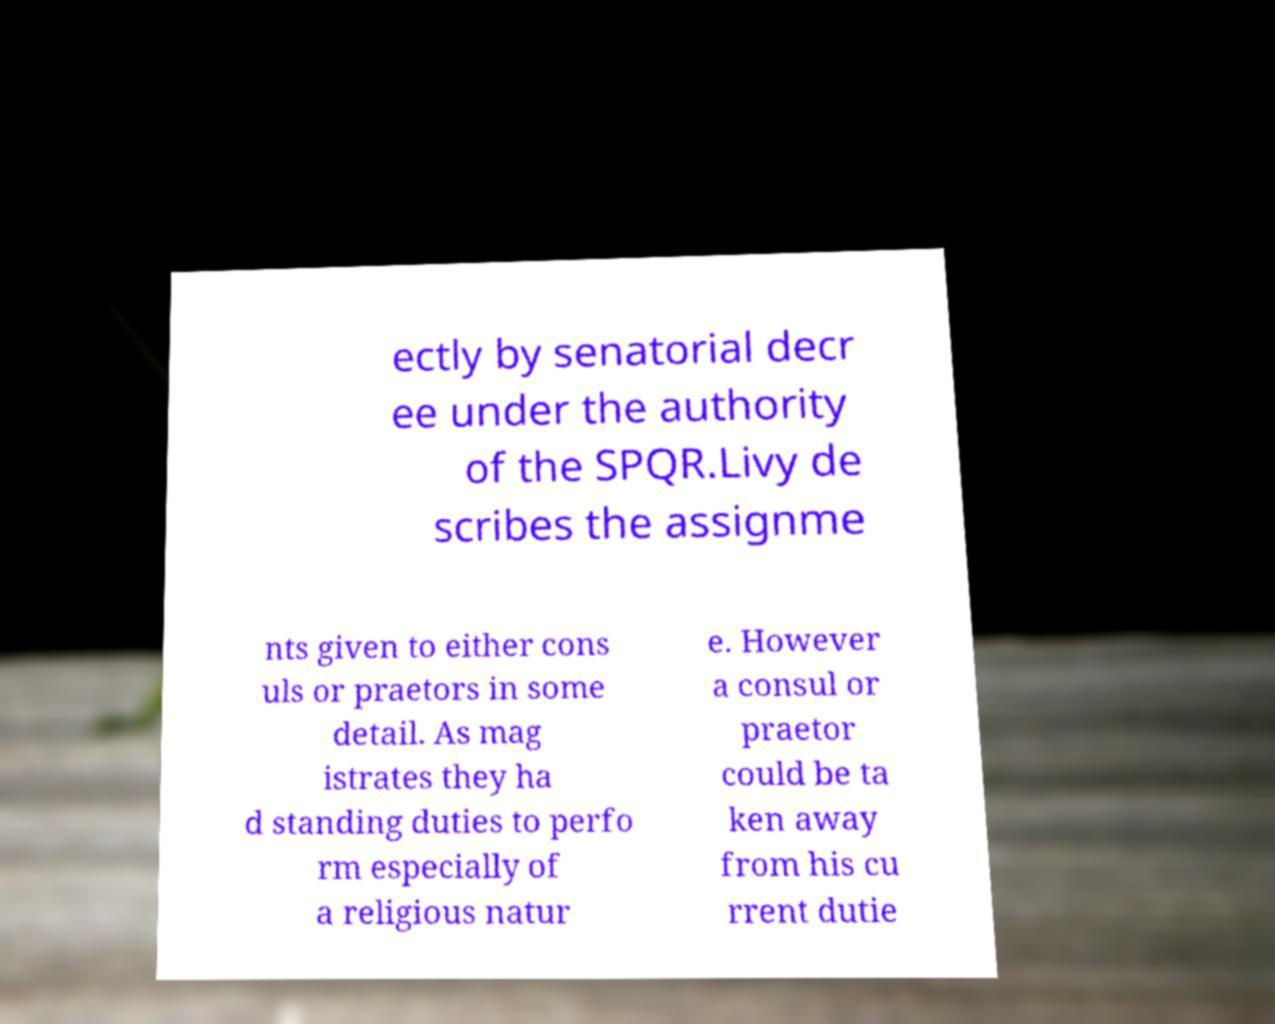Please read and relay the text visible in this image. What does it say? ectly by senatorial decr ee under the authority of the SPQR.Livy de scribes the assignme nts given to either cons uls or praetors in some detail. As mag istrates they ha d standing duties to perfo rm especially of a religious natur e. However a consul or praetor could be ta ken away from his cu rrent dutie 